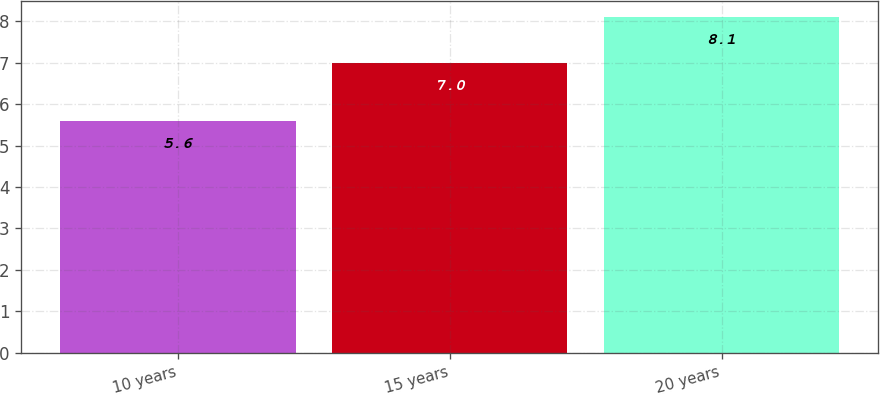<chart> <loc_0><loc_0><loc_500><loc_500><bar_chart><fcel>10 years<fcel>15 years<fcel>20 years<nl><fcel>5.6<fcel>7<fcel>8.1<nl></chart> 